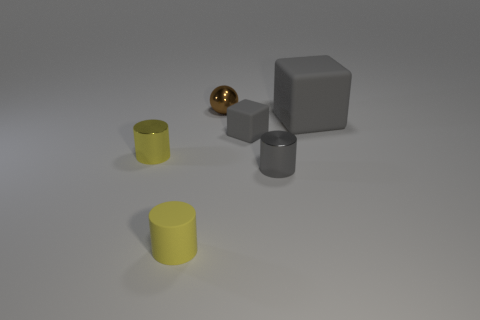What number of metal objects are either brown cubes or tiny balls?
Your answer should be compact. 1. There is a yellow thing that is the same material as the gray cylinder; what is its shape?
Offer a terse response. Cylinder. What number of things are right of the tiny brown metallic thing and in front of the tiny rubber cube?
Give a very brief answer. 1. Are there any other things that are the same shape as the small brown metal thing?
Provide a succinct answer. No. There is a gray matte thing that is on the right side of the small gray cylinder; what is its size?
Your answer should be compact. Large. What number of other objects are the same color as the small block?
Provide a succinct answer. 2. What is the material of the tiny gray thing that is in front of the shiny thing that is left of the tiny brown sphere?
Provide a succinct answer. Metal. There is a thing that is behind the large object; does it have the same color as the big matte thing?
Keep it short and to the point. No. Is there anything else that has the same material as the large gray block?
Give a very brief answer. Yes. What number of other gray matte things have the same shape as the tiny gray matte thing?
Give a very brief answer. 1. 